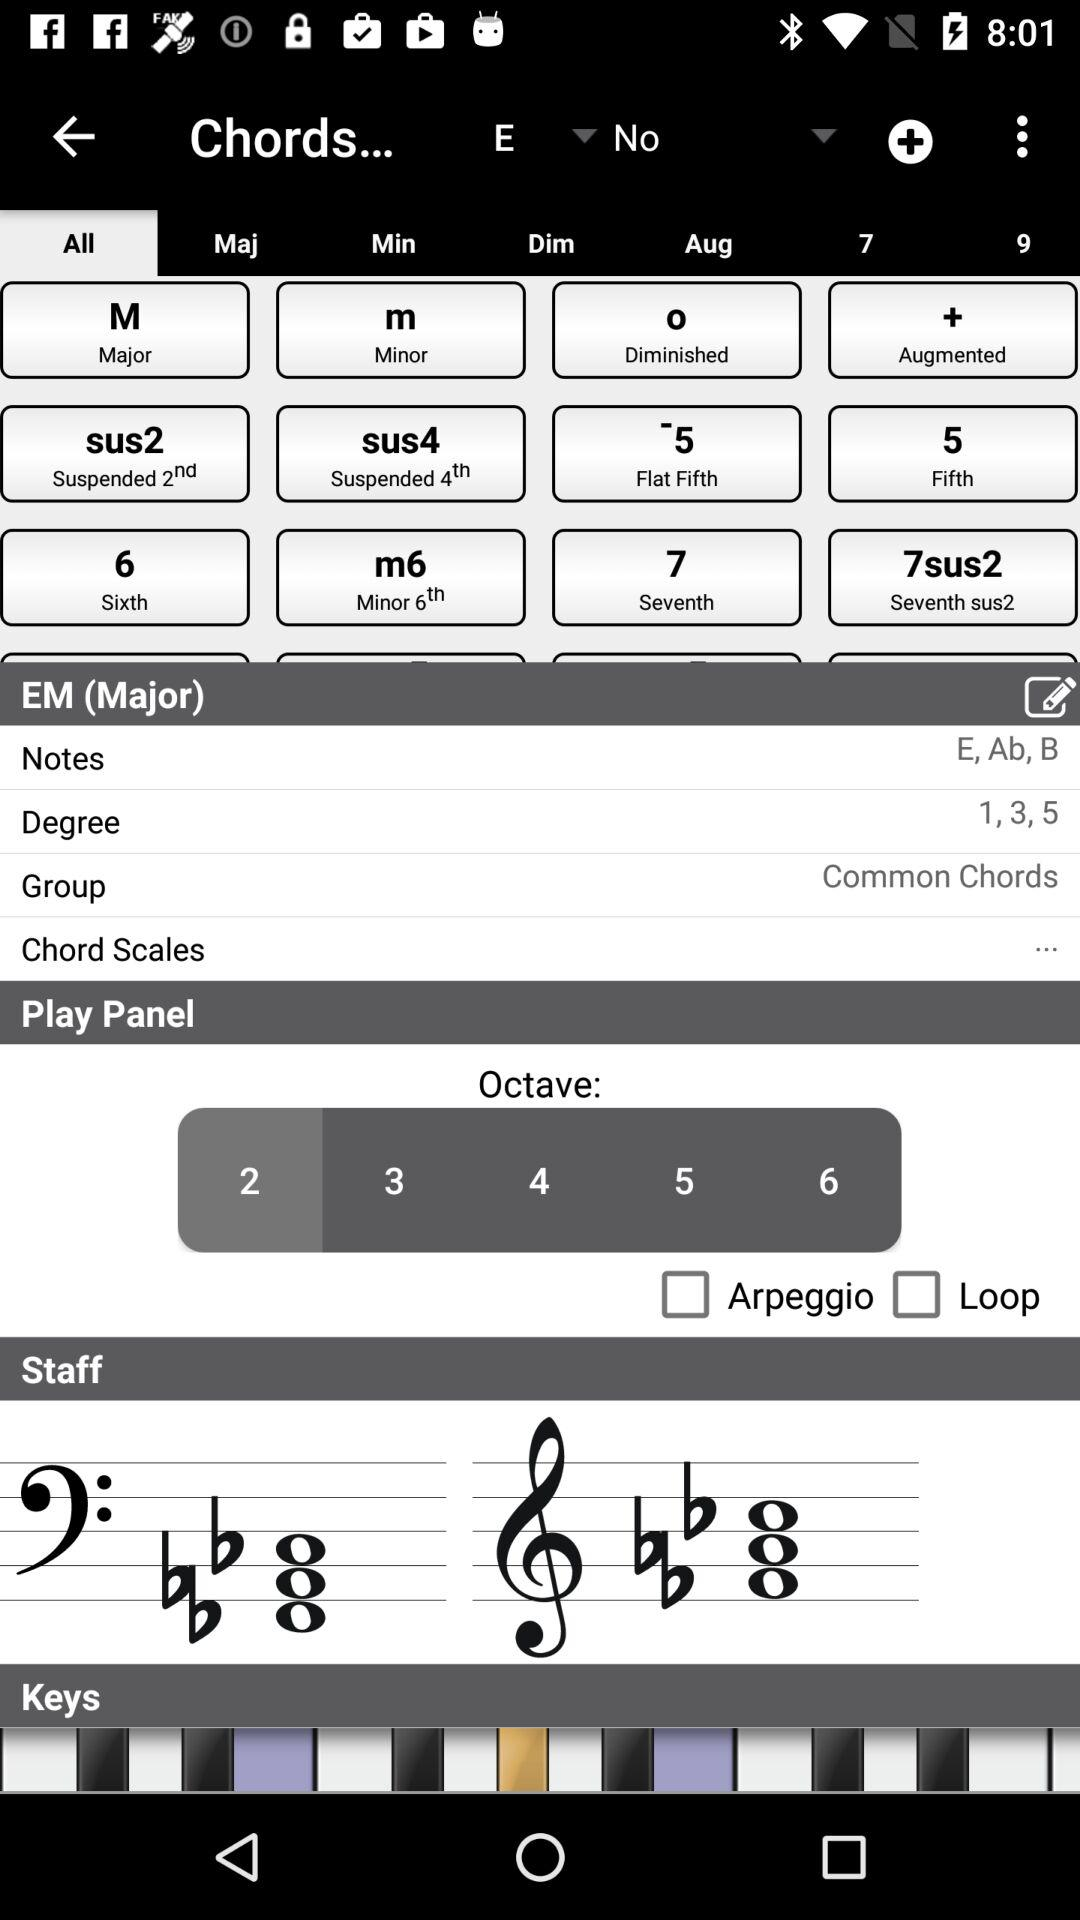What is mentioned in the "Group" of "EM (Major)"? In the "Group" of "EM (Major)" common chords is mentioned. 